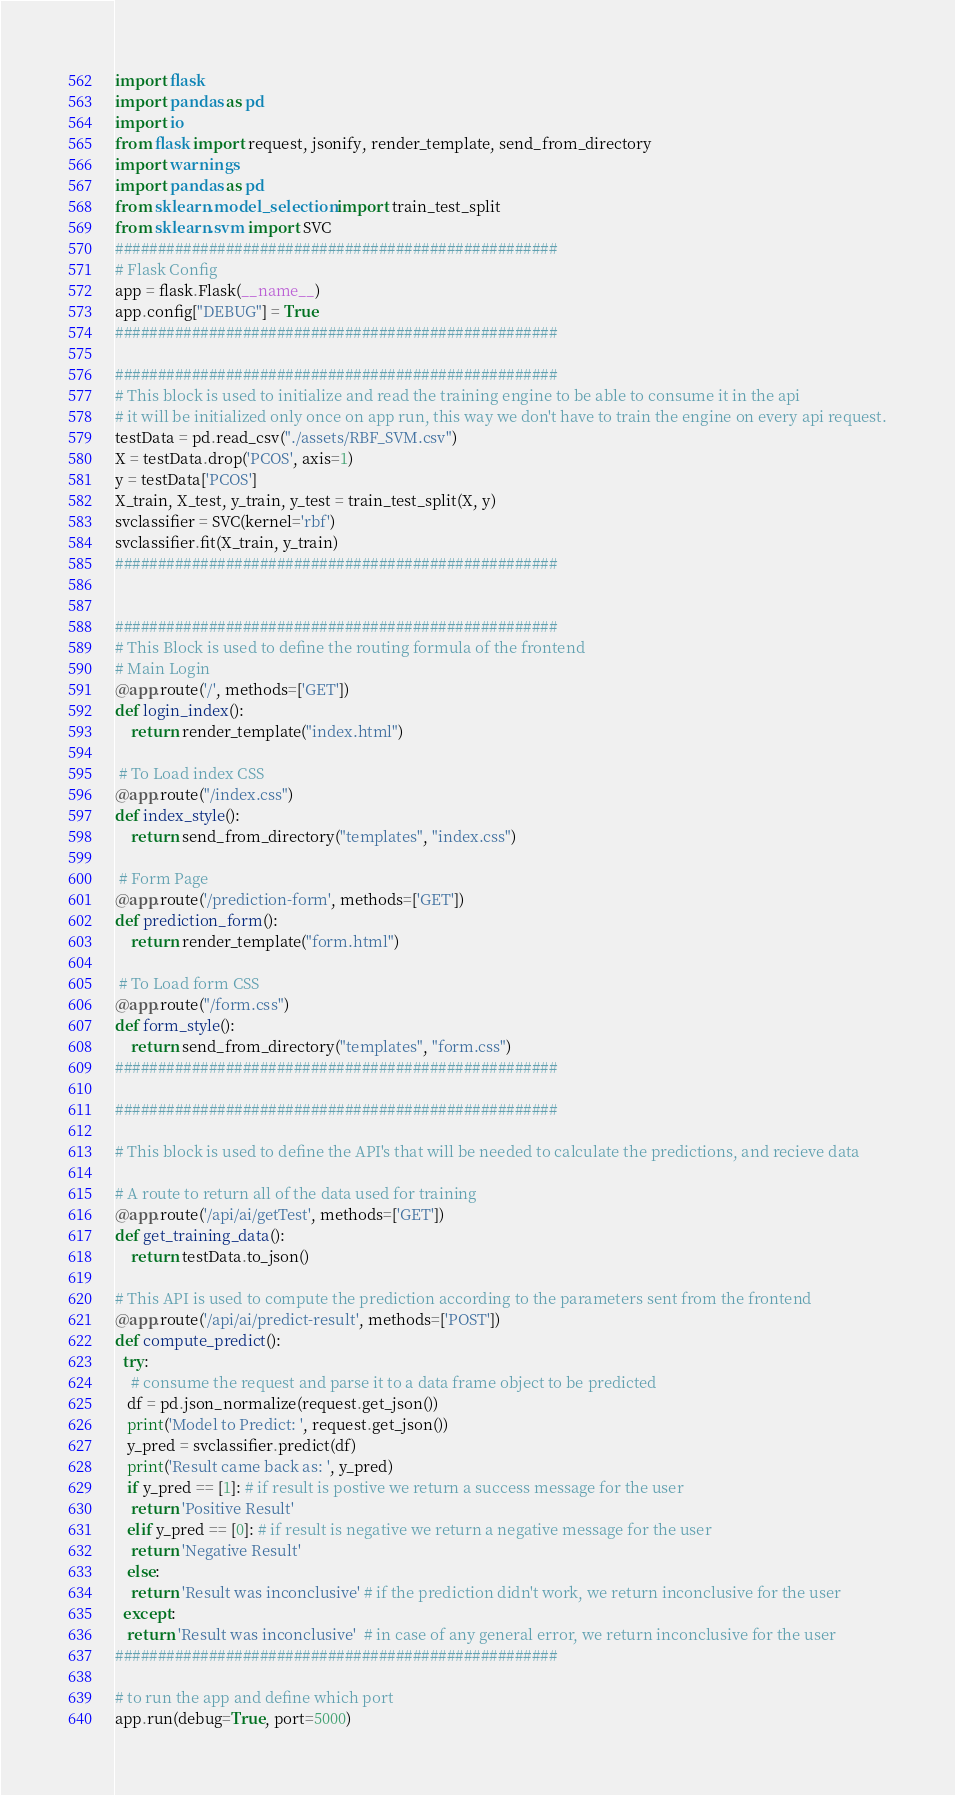Convert code to text. <code><loc_0><loc_0><loc_500><loc_500><_Python_>import flask
import pandas as pd
import io
from flask import request, jsonify, render_template, send_from_directory
import warnings
import pandas as pd
from sklearn.model_selection import train_test_split
from sklearn.svm import SVC
####################################################
# Flask Config
app = flask.Flask(__name__)
app.config["DEBUG"] = True
####################################################

####################################################
# This block is used to initialize and read the training engine to be able to consume it in the api
# it will be initialized only once on app run, this way we don't have to train the engine on every api request.
testData = pd.read_csv("./assets/RBF_SVM.csv")
X = testData.drop('PCOS', axis=1)
y = testData['PCOS']
X_train, X_test, y_train, y_test = train_test_split(X, y)
svclassifier = SVC(kernel='rbf')
svclassifier.fit(X_train, y_train)
####################################################


####################################################
# This Block is used to define the routing formula of the frontend
# Main Login 
@app.route('/', methods=['GET'])
def login_index():
    return render_template("index.html")
  
 # To Load index CSS 
@app.route("/index.css")
def index_style():
    return send_from_directory("templates", "index.css")

 # Form Page 
@app.route('/prediction-form', methods=['GET'])
def prediction_form():
    return render_template("form.html")

 # To Load form CSS 
@app.route("/form.css")
def form_style():
    return send_from_directory("templates", "form.css")
####################################################

####################################################

# This block is used to define the API's that will be needed to calculate the predictions, and recieve data

# A route to return all of the data used for training
@app.route('/api/ai/getTest', methods=['GET'])
def get_training_data():
    return testData.to_json()

# This API is used to compute the prediction according to the parameters sent from the frontend
@app.route('/api/ai/predict-result', methods=['POST'])
def compute_predict():
  try:
    # consume the request and parse it to a data frame object to be predicted
   df = pd.json_normalize(request.get_json())
   print('Model to Predict: ', request.get_json())
   y_pred = svclassifier.predict(df)
   print('Result came back as: ', y_pred)
   if y_pred == [1]: # if result is postive we return a success message for the user
    return 'Positive Result'
   elif y_pred == [0]: # if result is negative we return a negative message for the user
    return 'Negative Result'
   else:
    return 'Result was inconclusive' # if the prediction didn't work, we return inconclusive for the user
  except:
   return 'Result was inconclusive'  # in case of any general error, we return inconclusive for the user
####################################################

# to run the app and define which port  
app.run(debug=True, port=5000)</code> 